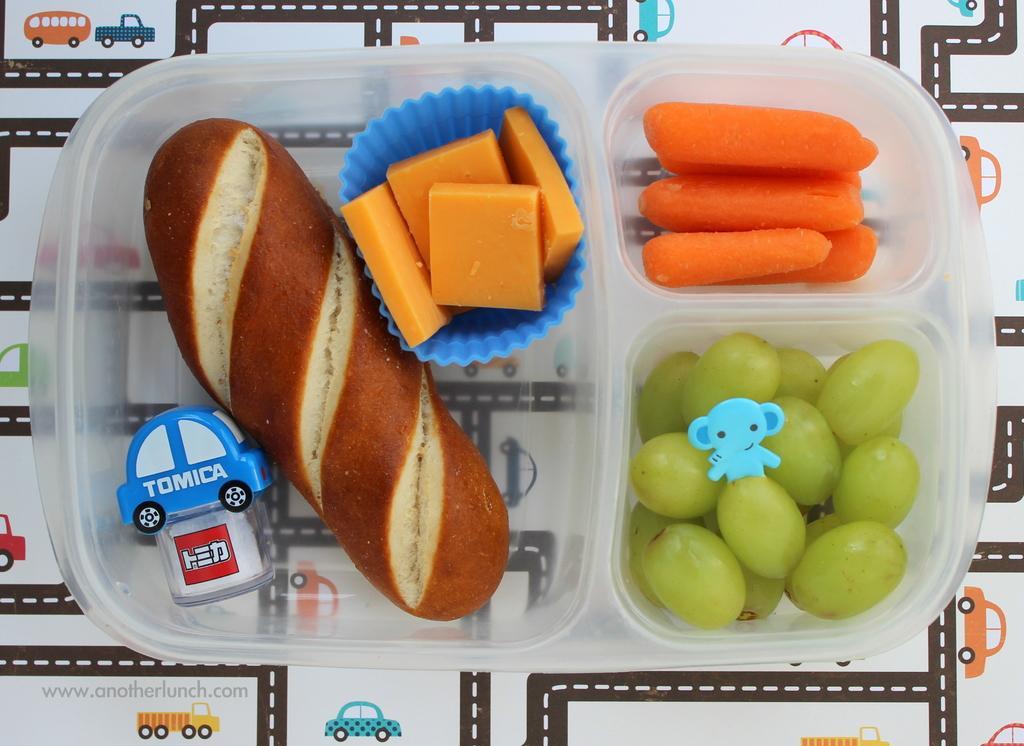In one or two sentences, can you explain what this image depicts? In this image I can see a plastic box in which bread, muffins, grapes, toy and carrots are there may be kept on the table. This image is taken may be in a room. 